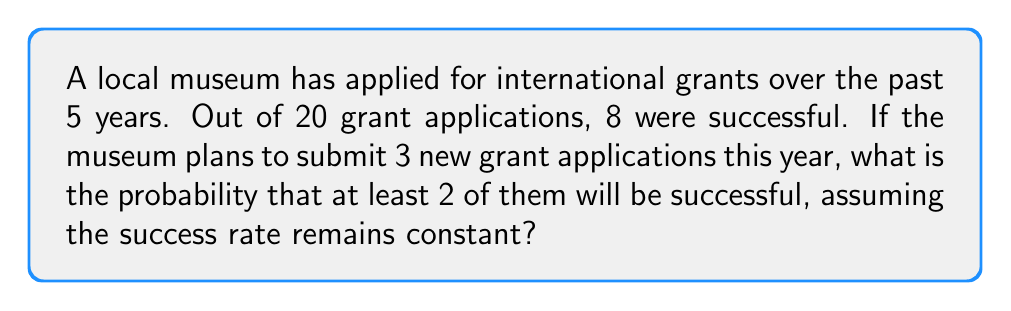What is the answer to this math problem? Let's approach this step-by-step:

1) First, we need to calculate the probability of success for a single grant application:
   $p = \frac{\text{successful applications}}{\text{total applications}} = \frac{8}{20} = 0.4$ or 40%

2) The probability of failure for a single application is:
   $q = 1 - p = 1 - 0.4 = 0.6$ or 60%

3) We want the probability of at least 2 successes out of 3 applications. This can happen in two ways:
   - Exactly 2 successes and 1 failure
   - All 3 successes

4) Let's use the binomial probability formula:
   $P(X = k) = \binom{n}{k} p^k q^{n-k}$
   where $n$ is the number of trials, $k$ is the number of successes, $p$ is the probability of success, and $q$ is the probability of failure.

5) Probability of exactly 2 successes:
   $P(X = 2) = \binom{3}{2} (0.4)^2 (0.6)^1 = 3 \cdot 0.16 \cdot 0.6 = 0.288$

6) Probability of 3 successes:
   $P(X = 3) = \binom{3}{3} (0.4)^3 (0.6)^0 = 1 \cdot 0.064 \cdot 1 = 0.064$

7) The probability of at least 2 successes is the sum of these probabilities:
   $P(X \geq 2) = P(X = 2) + P(X = 3) = 0.288 + 0.064 = 0.352$
Answer: 0.352 or 35.2% 